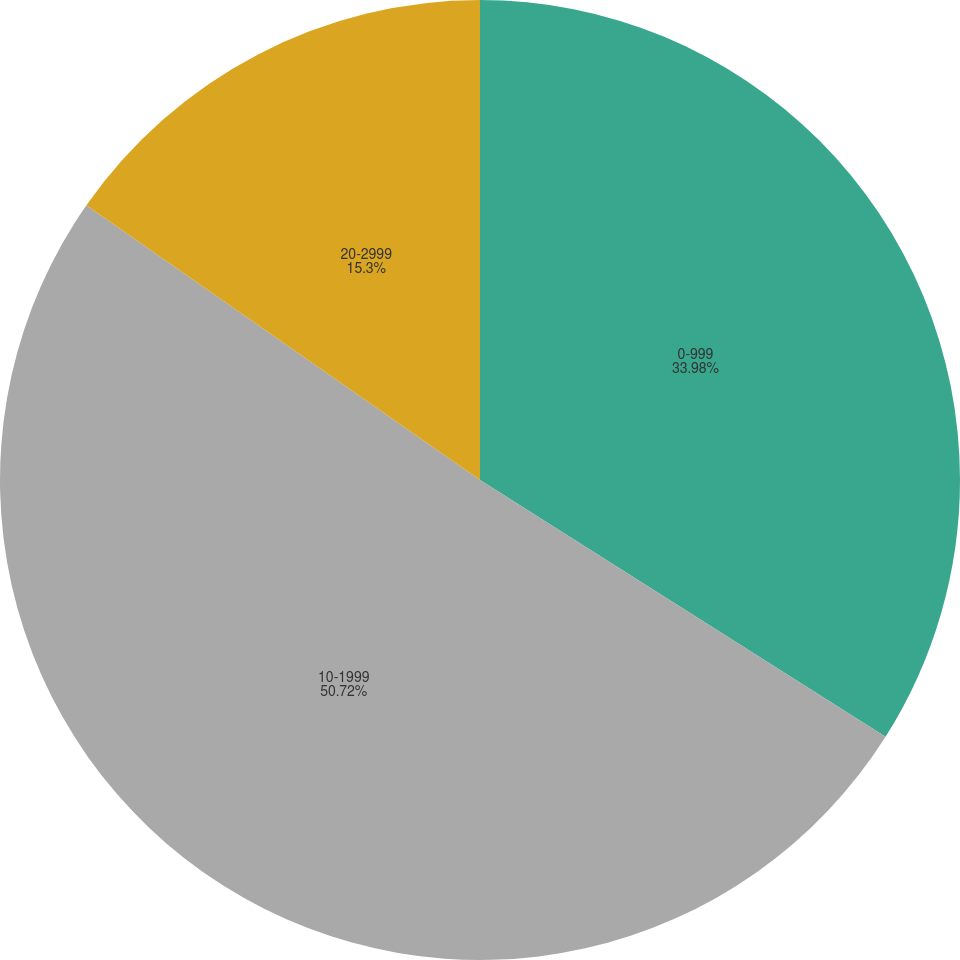Convert chart to OTSL. <chart><loc_0><loc_0><loc_500><loc_500><pie_chart><fcel>0-999<fcel>10-1999<fcel>20-2999<nl><fcel>33.98%<fcel>50.71%<fcel>15.3%<nl></chart> 